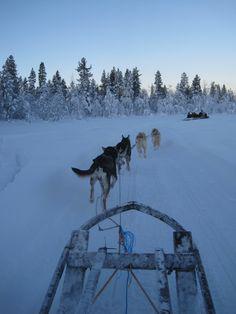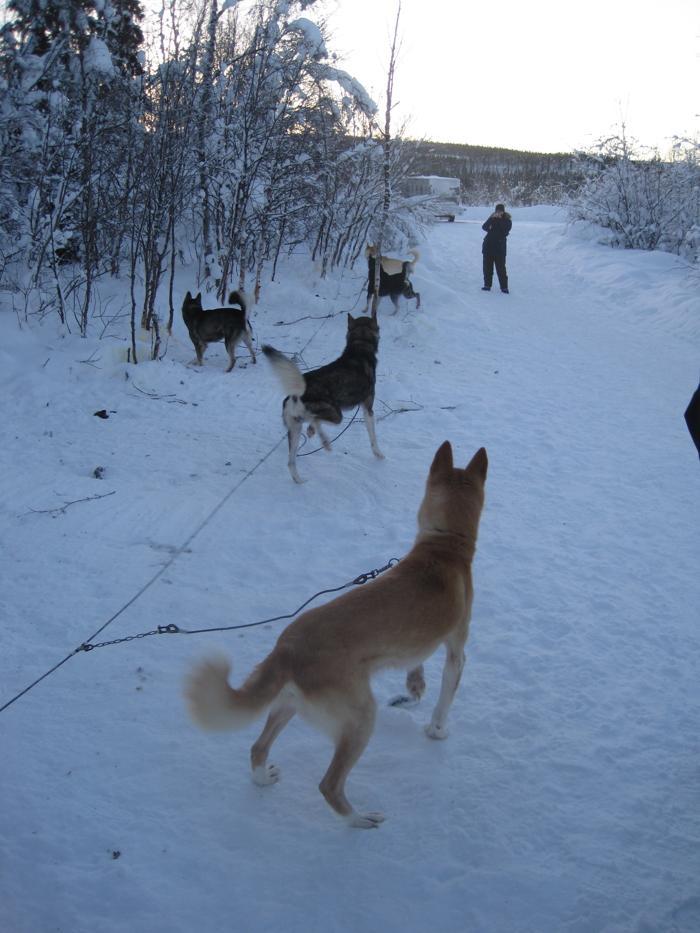The first image is the image on the left, the second image is the image on the right. For the images displayed, is the sentence "In the left image, the sled dog team is taking a break." factually correct? Answer yes or no. No. The first image is the image on the left, the second image is the image on the right. Analyze the images presented: Is the assertion "In one of the images the photographer's sled is being pulled by dogs." valid? Answer yes or no. Yes. 